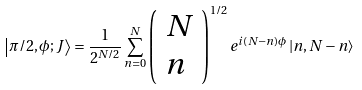<formula> <loc_0><loc_0><loc_500><loc_500>\left | \pi / 2 , \phi ; J \right \rangle = \frac { 1 } { 2 ^ { N / 2 } } \sum _ { n = 0 } ^ { N } \left ( \begin{array} { l } N \\ n \end{array} \right ) ^ { 1 / 2 } e ^ { i \left ( N - n \right ) \phi } \left | n , N - n \right \rangle</formula> 